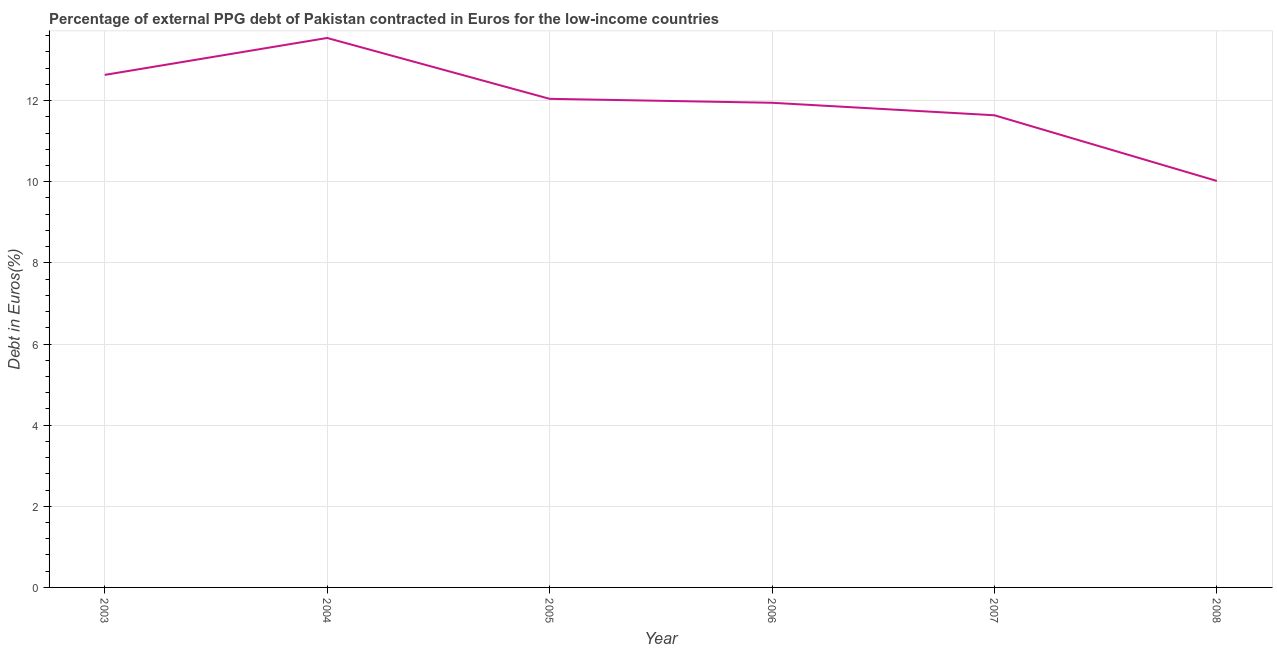What is the currency composition of ppg debt in 2007?
Give a very brief answer. 11.64. Across all years, what is the maximum currency composition of ppg debt?
Keep it short and to the point. 13.54. Across all years, what is the minimum currency composition of ppg debt?
Offer a very short reply. 10.02. In which year was the currency composition of ppg debt minimum?
Your response must be concise. 2008. What is the sum of the currency composition of ppg debt?
Give a very brief answer. 71.83. What is the difference between the currency composition of ppg debt in 2004 and 2006?
Offer a very short reply. 1.6. What is the average currency composition of ppg debt per year?
Your answer should be compact. 11.97. What is the median currency composition of ppg debt?
Make the answer very short. 12. What is the ratio of the currency composition of ppg debt in 2003 to that in 2008?
Offer a very short reply. 1.26. Is the currency composition of ppg debt in 2004 less than that in 2007?
Give a very brief answer. No. What is the difference between the highest and the second highest currency composition of ppg debt?
Your answer should be very brief. 0.91. Is the sum of the currency composition of ppg debt in 2004 and 2006 greater than the maximum currency composition of ppg debt across all years?
Keep it short and to the point. Yes. What is the difference between the highest and the lowest currency composition of ppg debt?
Provide a succinct answer. 3.52. What is the difference between two consecutive major ticks on the Y-axis?
Your answer should be very brief. 2. Are the values on the major ticks of Y-axis written in scientific E-notation?
Provide a succinct answer. No. Does the graph contain grids?
Offer a terse response. Yes. What is the title of the graph?
Offer a terse response. Percentage of external PPG debt of Pakistan contracted in Euros for the low-income countries. What is the label or title of the Y-axis?
Offer a very short reply. Debt in Euros(%). What is the Debt in Euros(%) in 2003?
Offer a terse response. 12.63. What is the Debt in Euros(%) in 2004?
Keep it short and to the point. 13.54. What is the Debt in Euros(%) of 2005?
Provide a succinct answer. 12.04. What is the Debt in Euros(%) in 2006?
Make the answer very short. 11.95. What is the Debt in Euros(%) of 2007?
Make the answer very short. 11.64. What is the Debt in Euros(%) in 2008?
Offer a terse response. 10.02. What is the difference between the Debt in Euros(%) in 2003 and 2004?
Offer a very short reply. -0.91. What is the difference between the Debt in Euros(%) in 2003 and 2005?
Provide a short and direct response. 0.59. What is the difference between the Debt in Euros(%) in 2003 and 2006?
Provide a short and direct response. 0.69. What is the difference between the Debt in Euros(%) in 2003 and 2007?
Give a very brief answer. 1. What is the difference between the Debt in Euros(%) in 2003 and 2008?
Your answer should be compact. 2.61. What is the difference between the Debt in Euros(%) in 2004 and 2005?
Provide a short and direct response. 1.5. What is the difference between the Debt in Euros(%) in 2004 and 2006?
Your response must be concise. 1.6. What is the difference between the Debt in Euros(%) in 2004 and 2007?
Your response must be concise. 1.91. What is the difference between the Debt in Euros(%) in 2004 and 2008?
Your answer should be compact. 3.52. What is the difference between the Debt in Euros(%) in 2005 and 2006?
Provide a short and direct response. 0.1. What is the difference between the Debt in Euros(%) in 2005 and 2007?
Make the answer very short. 0.41. What is the difference between the Debt in Euros(%) in 2005 and 2008?
Offer a very short reply. 2.02. What is the difference between the Debt in Euros(%) in 2006 and 2007?
Your response must be concise. 0.31. What is the difference between the Debt in Euros(%) in 2006 and 2008?
Your answer should be very brief. 1.93. What is the difference between the Debt in Euros(%) in 2007 and 2008?
Offer a terse response. 1.62. What is the ratio of the Debt in Euros(%) in 2003 to that in 2004?
Ensure brevity in your answer.  0.93. What is the ratio of the Debt in Euros(%) in 2003 to that in 2005?
Give a very brief answer. 1.05. What is the ratio of the Debt in Euros(%) in 2003 to that in 2006?
Provide a succinct answer. 1.06. What is the ratio of the Debt in Euros(%) in 2003 to that in 2007?
Provide a short and direct response. 1.09. What is the ratio of the Debt in Euros(%) in 2003 to that in 2008?
Give a very brief answer. 1.26. What is the ratio of the Debt in Euros(%) in 2004 to that in 2006?
Provide a short and direct response. 1.13. What is the ratio of the Debt in Euros(%) in 2004 to that in 2007?
Your answer should be very brief. 1.16. What is the ratio of the Debt in Euros(%) in 2004 to that in 2008?
Provide a succinct answer. 1.35. What is the ratio of the Debt in Euros(%) in 2005 to that in 2007?
Offer a terse response. 1.03. What is the ratio of the Debt in Euros(%) in 2005 to that in 2008?
Make the answer very short. 1.2. What is the ratio of the Debt in Euros(%) in 2006 to that in 2008?
Your response must be concise. 1.19. What is the ratio of the Debt in Euros(%) in 2007 to that in 2008?
Keep it short and to the point. 1.16. 